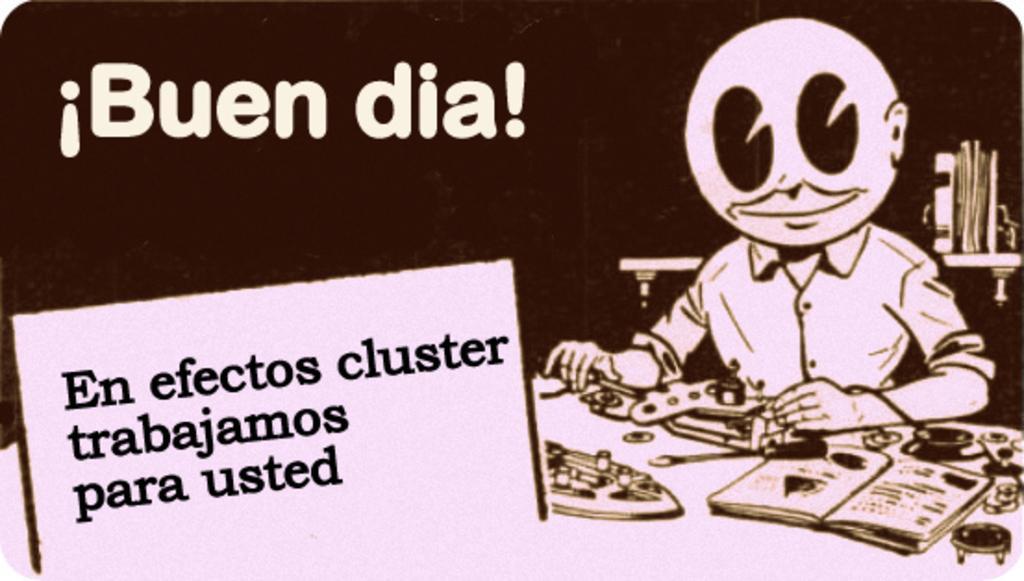In one or two sentences, can you explain what this image depicts? In this picture I can see a poster with some text and a picture on the side. 